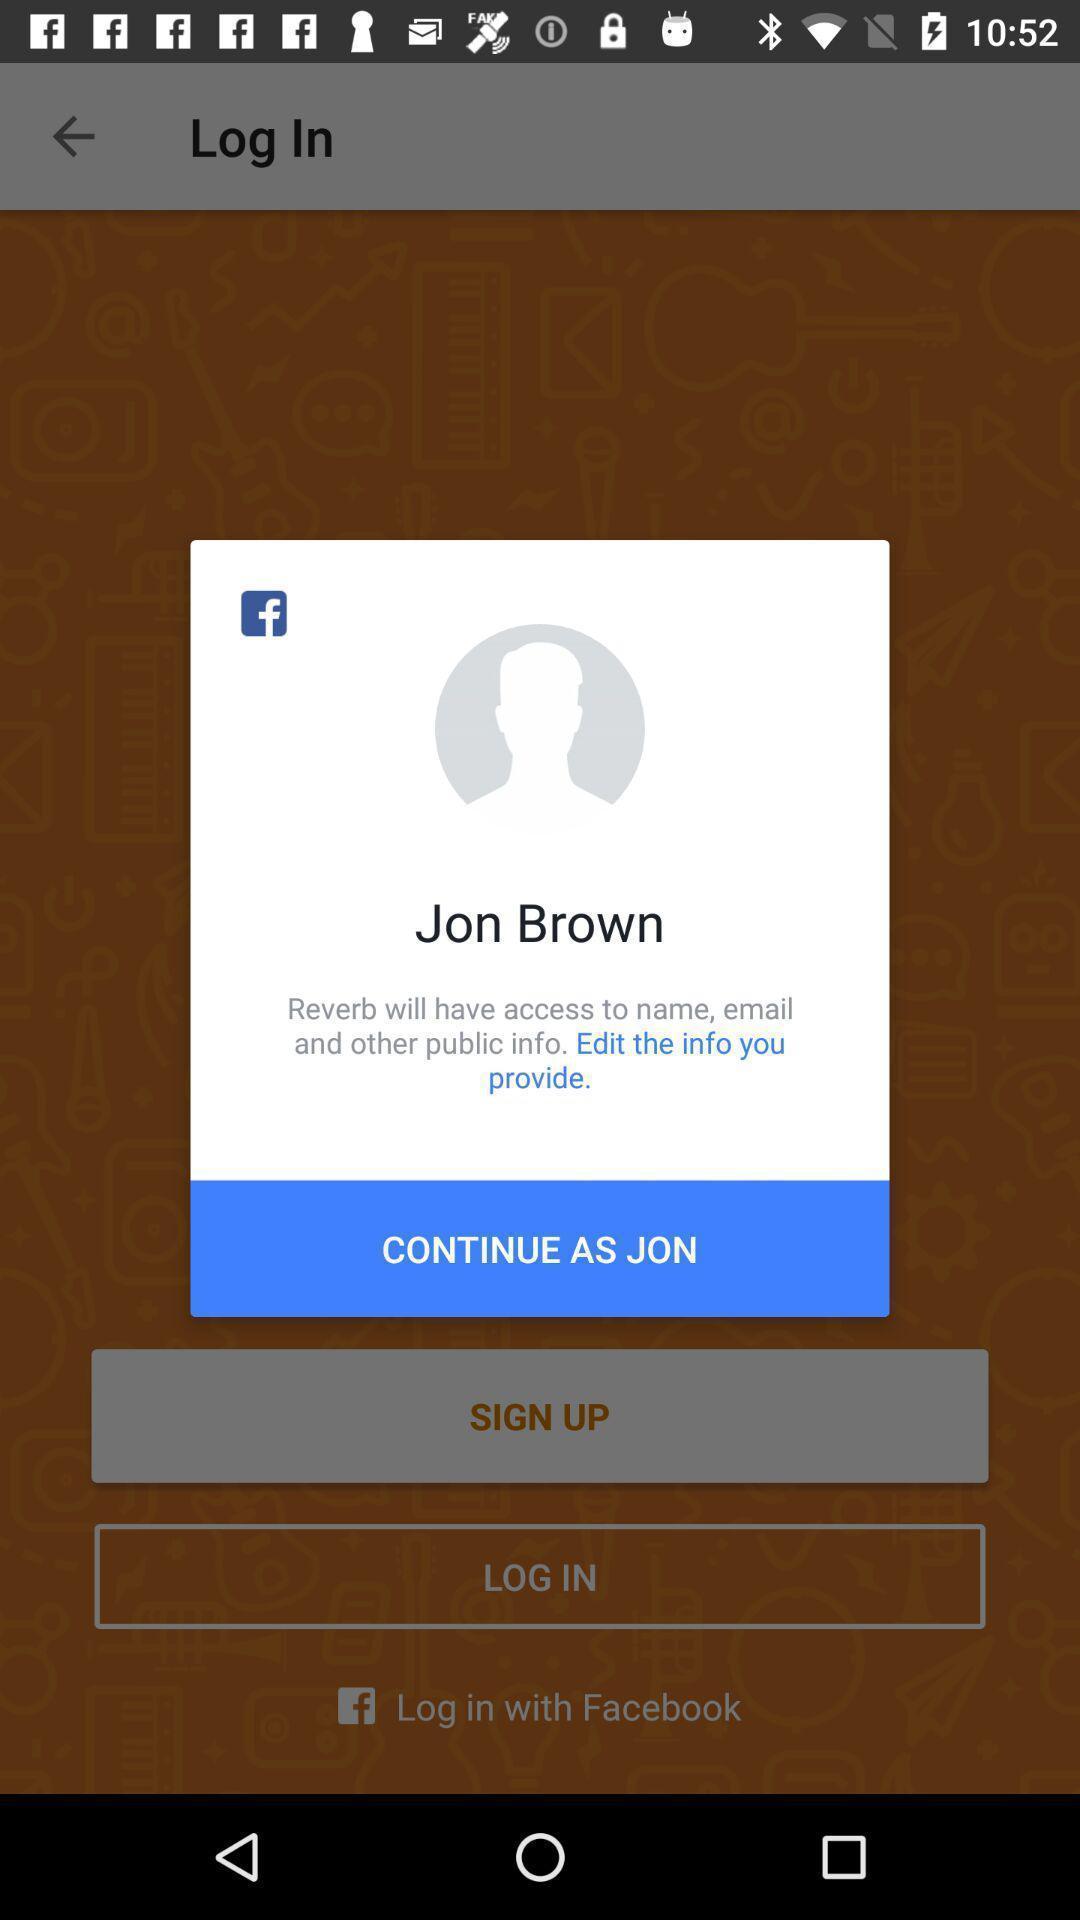Provide a description of this screenshot. Pop-up showing continue to login into a social app. 